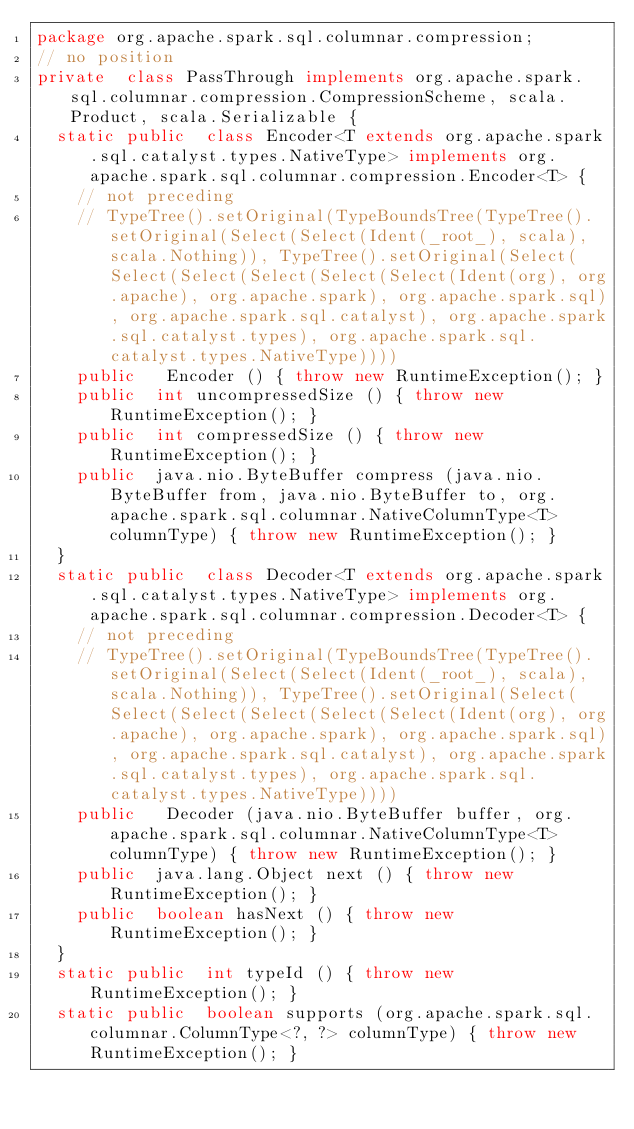<code> <loc_0><loc_0><loc_500><loc_500><_Java_>package org.apache.spark.sql.columnar.compression;
// no position
private  class PassThrough implements org.apache.spark.sql.columnar.compression.CompressionScheme, scala.Product, scala.Serializable {
  static public  class Encoder<T extends org.apache.spark.sql.catalyst.types.NativeType> implements org.apache.spark.sql.columnar.compression.Encoder<T> {
    // not preceding
    // TypeTree().setOriginal(TypeBoundsTree(TypeTree().setOriginal(Select(Select(Ident(_root_), scala), scala.Nothing)), TypeTree().setOriginal(Select(Select(Select(Select(Select(Select(Ident(org), org.apache), org.apache.spark), org.apache.spark.sql), org.apache.spark.sql.catalyst), org.apache.spark.sql.catalyst.types), org.apache.spark.sql.catalyst.types.NativeType))))
    public   Encoder () { throw new RuntimeException(); }
    public  int uncompressedSize () { throw new RuntimeException(); }
    public  int compressedSize () { throw new RuntimeException(); }
    public  java.nio.ByteBuffer compress (java.nio.ByteBuffer from, java.nio.ByteBuffer to, org.apache.spark.sql.columnar.NativeColumnType<T> columnType) { throw new RuntimeException(); }
  }
  static public  class Decoder<T extends org.apache.spark.sql.catalyst.types.NativeType> implements org.apache.spark.sql.columnar.compression.Decoder<T> {
    // not preceding
    // TypeTree().setOriginal(TypeBoundsTree(TypeTree().setOriginal(Select(Select(Ident(_root_), scala), scala.Nothing)), TypeTree().setOriginal(Select(Select(Select(Select(Select(Select(Ident(org), org.apache), org.apache.spark), org.apache.spark.sql), org.apache.spark.sql.catalyst), org.apache.spark.sql.catalyst.types), org.apache.spark.sql.catalyst.types.NativeType))))
    public   Decoder (java.nio.ByteBuffer buffer, org.apache.spark.sql.columnar.NativeColumnType<T> columnType) { throw new RuntimeException(); }
    public  java.lang.Object next () { throw new RuntimeException(); }
    public  boolean hasNext () { throw new RuntimeException(); }
  }
  static public  int typeId () { throw new RuntimeException(); }
  static public  boolean supports (org.apache.spark.sql.columnar.ColumnType<?, ?> columnType) { throw new RuntimeException(); }</code> 